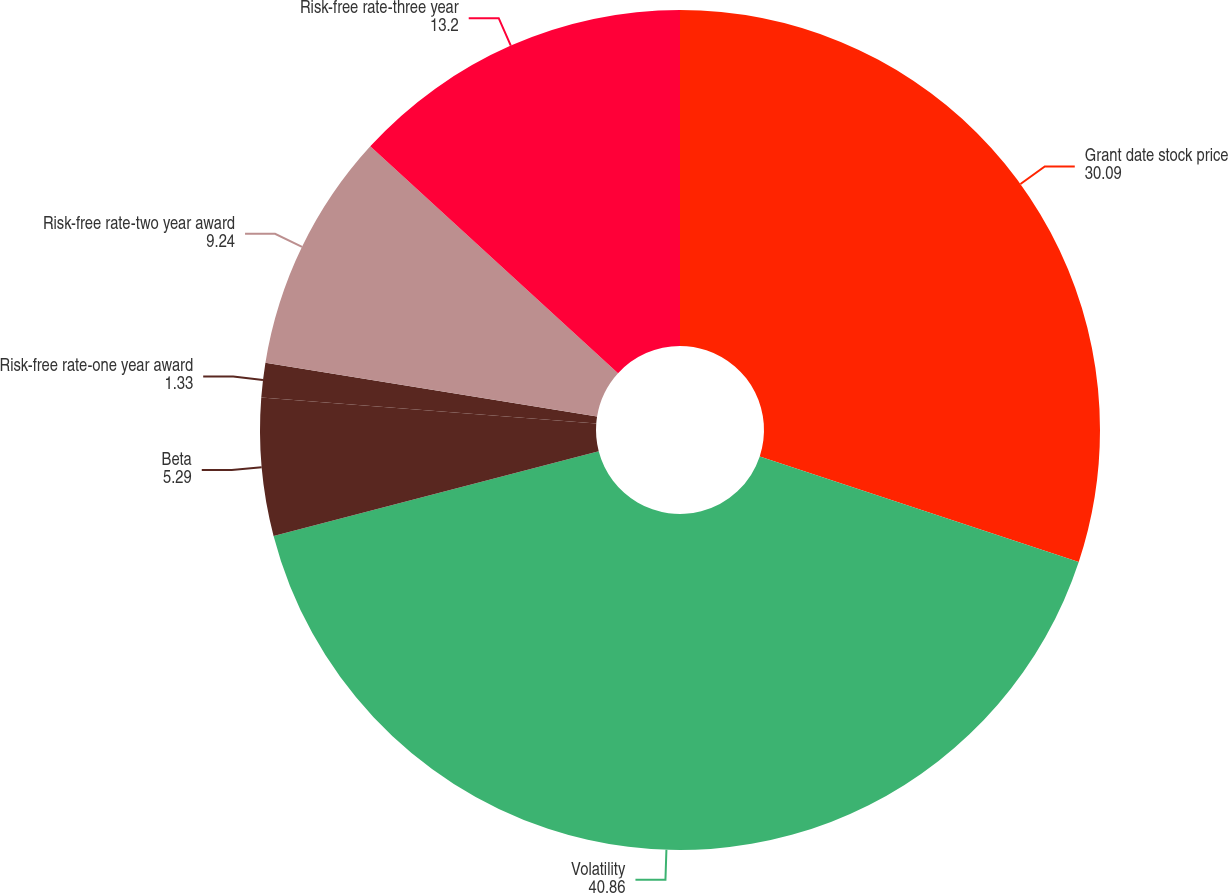Convert chart to OTSL. <chart><loc_0><loc_0><loc_500><loc_500><pie_chart><fcel>Grant date stock price<fcel>Volatility<fcel>Beta<fcel>Risk-free rate-one year award<fcel>Risk-free rate-two year award<fcel>Risk-free rate-three year<nl><fcel>30.09%<fcel>40.86%<fcel>5.29%<fcel>1.33%<fcel>9.24%<fcel>13.2%<nl></chart> 